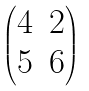Convert formula to latex. <formula><loc_0><loc_0><loc_500><loc_500>\begin{pmatrix} 4 & 2 \\ 5 & 6 \end{pmatrix}</formula> 